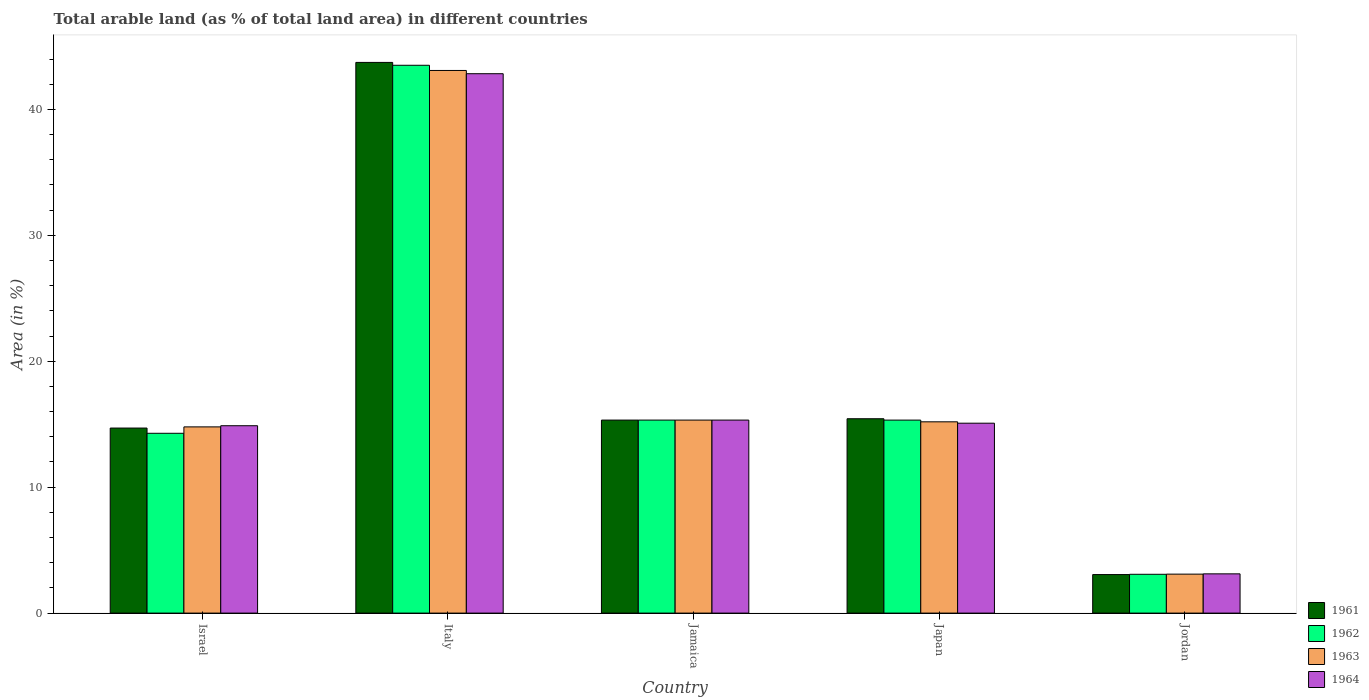What is the label of the 5th group of bars from the left?
Your answer should be compact. Jordan. What is the percentage of arable land in 1964 in Israel?
Offer a very short reply. 14.88. Across all countries, what is the maximum percentage of arable land in 1961?
Provide a succinct answer. 43.73. Across all countries, what is the minimum percentage of arable land in 1963?
Keep it short and to the point. 3.09. In which country was the percentage of arable land in 1962 minimum?
Provide a short and direct response. Jordan. What is the total percentage of arable land in 1962 in the graph?
Make the answer very short. 91.52. What is the difference between the percentage of arable land in 1964 in Israel and that in Japan?
Your response must be concise. -0.2. What is the difference between the percentage of arable land in 1963 in Jamaica and the percentage of arable land in 1964 in Italy?
Provide a succinct answer. -27.51. What is the average percentage of arable land in 1963 per country?
Offer a very short reply. 18.3. What is the difference between the percentage of arable land of/in 1961 and percentage of arable land of/in 1963 in Jordan?
Offer a very short reply. -0.03. What is the ratio of the percentage of arable land in 1961 in Italy to that in Japan?
Your response must be concise. 2.83. What is the difference between the highest and the second highest percentage of arable land in 1962?
Make the answer very short. 28.18. What is the difference between the highest and the lowest percentage of arable land in 1964?
Keep it short and to the point. 39.72. Is the sum of the percentage of arable land in 1962 in Jamaica and Japan greater than the maximum percentage of arable land in 1963 across all countries?
Your answer should be compact. No. Is it the case that in every country, the sum of the percentage of arable land in 1961 and percentage of arable land in 1962 is greater than the sum of percentage of arable land in 1964 and percentage of arable land in 1963?
Make the answer very short. No. What does the 1st bar from the right in Jamaica represents?
Keep it short and to the point. 1964. Is it the case that in every country, the sum of the percentage of arable land in 1964 and percentage of arable land in 1962 is greater than the percentage of arable land in 1963?
Make the answer very short. Yes. How many bars are there?
Make the answer very short. 20. Are all the bars in the graph horizontal?
Offer a very short reply. No. How many countries are there in the graph?
Provide a succinct answer. 5. Does the graph contain any zero values?
Give a very brief answer. No. What is the title of the graph?
Your answer should be very brief. Total arable land (as % of total land area) in different countries. Does "1996" appear as one of the legend labels in the graph?
Your response must be concise. No. What is the label or title of the X-axis?
Give a very brief answer. Country. What is the label or title of the Y-axis?
Make the answer very short. Area (in %). What is the Area (in %) of 1961 in Israel?
Your answer should be compact. 14.7. What is the Area (in %) in 1962 in Israel?
Make the answer very short. 14.28. What is the Area (in %) in 1963 in Israel?
Provide a succinct answer. 14.79. What is the Area (in %) of 1964 in Israel?
Give a very brief answer. 14.88. What is the Area (in %) of 1961 in Italy?
Offer a terse response. 43.73. What is the Area (in %) in 1962 in Italy?
Offer a very short reply. 43.5. What is the Area (in %) in 1963 in Italy?
Offer a terse response. 43.09. What is the Area (in %) in 1964 in Italy?
Your answer should be compact. 42.83. What is the Area (in %) in 1961 in Jamaica?
Provide a short and direct response. 15.33. What is the Area (in %) in 1962 in Jamaica?
Offer a terse response. 15.33. What is the Area (in %) in 1963 in Jamaica?
Make the answer very short. 15.33. What is the Area (in %) in 1964 in Jamaica?
Your response must be concise. 15.33. What is the Area (in %) in 1961 in Japan?
Your answer should be compact. 15.43. What is the Area (in %) of 1962 in Japan?
Your answer should be very brief. 15.33. What is the Area (in %) in 1963 in Japan?
Your response must be concise. 15.19. What is the Area (in %) of 1964 in Japan?
Provide a succinct answer. 15.08. What is the Area (in %) in 1961 in Jordan?
Provide a short and direct response. 3.06. What is the Area (in %) in 1962 in Jordan?
Provide a succinct answer. 3.08. What is the Area (in %) of 1963 in Jordan?
Provide a succinct answer. 3.09. What is the Area (in %) in 1964 in Jordan?
Make the answer very short. 3.12. Across all countries, what is the maximum Area (in %) in 1961?
Provide a short and direct response. 43.73. Across all countries, what is the maximum Area (in %) in 1962?
Your answer should be compact. 43.5. Across all countries, what is the maximum Area (in %) in 1963?
Provide a succinct answer. 43.09. Across all countries, what is the maximum Area (in %) of 1964?
Offer a terse response. 42.83. Across all countries, what is the minimum Area (in %) of 1961?
Make the answer very short. 3.06. Across all countries, what is the minimum Area (in %) in 1962?
Your answer should be very brief. 3.08. Across all countries, what is the minimum Area (in %) in 1963?
Provide a succinct answer. 3.09. Across all countries, what is the minimum Area (in %) in 1964?
Your answer should be very brief. 3.12. What is the total Area (in %) of 1961 in the graph?
Your answer should be compact. 92.25. What is the total Area (in %) in 1962 in the graph?
Your answer should be very brief. 91.52. What is the total Area (in %) of 1963 in the graph?
Provide a short and direct response. 91.49. What is the total Area (in %) in 1964 in the graph?
Give a very brief answer. 91.24. What is the difference between the Area (in %) in 1961 in Israel and that in Italy?
Your response must be concise. -29.04. What is the difference between the Area (in %) of 1962 in Israel and that in Italy?
Make the answer very short. -29.23. What is the difference between the Area (in %) in 1963 in Israel and that in Italy?
Your answer should be very brief. -28.31. What is the difference between the Area (in %) in 1964 in Israel and that in Italy?
Offer a very short reply. -27.95. What is the difference between the Area (in %) in 1961 in Israel and that in Jamaica?
Keep it short and to the point. -0.63. What is the difference between the Area (in %) of 1962 in Israel and that in Jamaica?
Ensure brevity in your answer.  -1.05. What is the difference between the Area (in %) in 1963 in Israel and that in Jamaica?
Your answer should be very brief. -0.54. What is the difference between the Area (in %) in 1964 in Israel and that in Jamaica?
Offer a very short reply. -0.45. What is the difference between the Area (in %) of 1961 in Israel and that in Japan?
Your response must be concise. -0.74. What is the difference between the Area (in %) in 1962 in Israel and that in Japan?
Give a very brief answer. -1.05. What is the difference between the Area (in %) of 1963 in Israel and that in Japan?
Your answer should be compact. -0.4. What is the difference between the Area (in %) in 1964 in Israel and that in Japan?
Your answer should be compact. -0.2. What is the difference between the Area (in %) of 1961 in Israel and that in Jordan?
Keep it short and to the point. 11.64. What is the difference between the Area (in %) in 1962 in Israel and that in Jordan?
Provide a short and direct response. 11.2. What is the difference between the Area (in %) in 1963 in Israel and that in Jordan?
Your answer should be compact. 11.69. What is the difference between the Area (in %) in 1964 in Israel and that in Jordan?
Keep it short and to the point. 11.76. What is the difference between the Area (in %) in 1961 in Italy and that in Jamaica?
Your response must be concise. 28.4. What is the difference between the Area (in %) of 1962 in Italy and that in Jamaica?
Make the answer very short. 28.18. What is the difference between the Area (in %) in 1963 in Italy and that in Jamaica?
Your answer should be very brief. 27.76. What is the difference between the Area (in %) in 1964 in Italy and that in Jamaica?
Make the answer very short. 27.51. What is the difference between the Area (in %) in 1961 in Italy and that in Japan?
Your answer should be very brief. 28.3. What is the difference between the Area (in %) in 1962 in Italy and that in Japan?
Provide a succinct answer. 28.18. What is the difference between the Area (in %) in 1963 in Italy and that in Japan?
Make the answer very short. 27.9. What is the difference between the Area (in %) in 1964 in Italy and that in Japan?
Give a very brief answer. 27.75. What is the difference between the Area (in %) of 1961 in Italy and that in Jordan?
Provide a short and direct response. 40.67. What is the difference between the Area (in %) of 1962 in Italy and that in Jordan?
Offer a terse response. 40.42. What is the difference between the Area (in %) of 1963 in Italy and that in Jordan?
Offer a terse response. 40. What is the difference between the Area (in %) in 1964 in Italy and that in Jordan?
Offer a terse response. 39.72. What is the difference between the Area (in %) in 1961 in Jamaica and that in Japan?
Your response must be concise. -0.11. What is the difference between the Area (in %) in 1962 in Jamaica and that in Japan?
Give a very brief answer. 0. What is the difference between the Area (in %) in 1963 in Jamaica and that in Japan?
Ensure brevity in your answer.  0.14. What is the difference between the Area (in %) in 1964 in Jamaica and that in Japan?
Provide a succinct answer. 0.25. What is the difference between the Area (in %) in 1961 in Jamaica and that in Jordan?
Your answer should be very brief. 12.27. What is the difference between the Area (in %) in 1962 in Jamaica and that in Jordan?
Give a very brief answer. 12.25. What is the difference between the Area (in %) of 1963 in Jamaica and that in Jordan?
Offer a very short reply. 12.23. What is the difference between the Area (in %) in 1964 in Jamaica and that in Jordan?
Provide a succinct answer. 12.21. What is the difference between the Area (in %) in 1961 in Japan and that in Jordan?
Offer a terse response. 12.38. What is the difference between the Area (in %) of 1962 in Japan and that in Jordan?
Make the answer very short. 12.24. What is the difference between the Area (in %) of 1963 in Japan and that in Jordan?
Your answer should be compact. 12.1. What is the difference between the Area (in %) of 1964 in Japan and that in Jordan?
Offer a very short reply. 11.96. What is the difference between the Area (in %) in 1961 in Israel and the Area (in %) in 1962 in Italy?
Keep it short and to the point. -28.81. What is the difference between the Area (in %) of 1961 in Israel and the Area (in %) of 1963 in Italy?
Keep it short and to the point. -28.4. What is the difference between the Area (in %) of 1961 in Israel and the Area (in %) of 1964 in Italy?
Provide a succinct answer. -28.14. What is the difference between the Area (in %) in 1962 in Israel and the Area (in %) in 1963 in Italy?
Provide a short and direct response. -28.81. What is the difference between the Area (in %) in 1962 in Israel and the Area (in %) in 1964 in Italy?
Your answer should be very brief. -28.56. What is the difference between the Area (in %) in 1963 in Israel and the Area (in %) in 1964 in Italy?
Your answer should be compact. -28.05. What is the difference between the Area (in %) of 1961 in Israel and the Area (in %) of 1962 in Jamaica?
Provide a short and direct response. -0.63. What is the difference between the Area (in %) of 1961 in Israel and the Area (in %) of 1963 in Jamaica?
Give a very brief answer. -0.63. What is the difference between the Area (in %) in 1961 in Israel and the Area (in %) in 1964 in Jamaica?
Your answer should be compact. -0.63. What is the difference between the Area (in %) in 1962 in Israel and the Area (in %) in 1963 in Jamaica?
Provide a succinct answer. -1.05. What is the difference between the Area (in %) in 1962 in Israel and the Area (in %) in 1964 in Jamaica?
Your answer should be very brief. -1.05. What is the difference between the Area (in %) of 1963 in Israel and the Area (in %) of 1964 in Jamaica?
Your answer should be very brief. -0.54. What is the difference between the Area (in %) in 1961 in Israel and the Area (in %) in 1962 in Japan?
Offer a very short reply. -0.63. What is the difference between the Area (in %) of 1961 in Israel and the Area (in %) of 1963 in Japan?
Give a very brief answer. -0.49. What is the difference between the Area (in %) of 1961 in Israel and the Area (in %) of 1964 in Japan?
Keep it short and to the point. -0.39. What is the difference between the Area (in %) of 1962 in Israel and the Area (in %) of 1963 in Japan?
Make the answer very short. -0.91. What is the difference between the Area (in %) in 1962 in Israel and the Area (in %) in 1964 in Japan?
Keep it short and to the point. -0.8. What is the difference between the Area (in %) in 1963 in Israel and the Area (in %) in 1964 in Japan?
Provide a succinct answer. -0.29. What is the difference between the Area (in %) in 1961 in Israel and the Area (in %) in 1962 in Jordan?
Offer a terse response. 11.61. What is the difference between the Area (in %) in 1961 in Israel and the Area (in %) in 1963 in Jordan?
Offer a very short reply. 11.6. What is the difference between the Area (in %) in 1961 in Israel and the Area (in %) in 1964 in Jordan?
Provide a succinct answer. 11.58. What is the difference between the Area (in %) of 1962 in Israel and the Area (in %) of 1963 in Jordan?
Offer a very short reply. 11.19. What is the difference between the Area (in %) of 1962 in Israel and the Area (in %) of 1964 in Jordan?
Provide a short and direct response. 11.16. What is the difference between the Area (in %) in 1963 in Israel and the Area (in %) in 1964 in Jordan?
Provide a succinct answer. 11.67. What is the difference between the Area (in %) in 1961 in Italy and the Area (in %) in 1962 in Jamaica?
Keep it short and to the point. 28.4. What is the difference between the Area (in %) of 1961 in Italy and the Area (in %) of 1963 in Jamaica?
Your answer should be very brief. 28.4. What is the difference between the Area (in %) in 1961 in Italy and the Area (in %) in 1964 in Jamaica?
Provide a succinct answer. 28.4. What is the difference between the Area (in %) of 1962 in Italy and the Area (in %) of 1963 in Jamaica?
Ensure brevity in your answer.  28.18. What is the difference between the Area (in %) in 1962 in Italy and the Area (in %) in 1964 in Jamaica?
Your answer should be compact. 28.18. What is the difference between the Area (in %) of 1963 in Italy and the Area (in %) of 1964 in Jamaica?
Ensure brevity in your answer.  27.76. What is the difference between the Area (in %) of 1961 in Italy and the Area (in %) of 1962 in Japan?
Ensure brevity in your answer.  28.41. What is the difference between the Area (in %) of 1961 in Italy and the Area (in %) of 1963 in Japan?
Keep it short and to the point. 28.54. What is the difference between the Area (in %) in 1961 in Italy and the Area (in %) in 1964 in Japan?
Give a very brief answer. 28.65. What is the difference between the Area (in %) in 1962 in Italy and the Area (in %) in 1963 in Japan?
Ensure brevity in your answer.  28.31. What is the difference between the Area (in %) of 1962 in Italy and the Area (in %) of 1964 in Japan?
Provide a short and direct response. 28.42. What is the difference between the Area (in %) of 1963 in Italy and the Area (in %) of 1964 in Japan?
Your response must be concise. 28.01. What is the difference between the Area (in %) in 1961 in Italy and the Area (in %) in 1962 in Jordan?
Ensure brevity in your answer.  40.65. What is the difference between the Area (in %) in 1961 in Italy and the Area (in %) in 1963 in Jordan?
Offer a very short reply. 40.64. What is the difference between the Area (in %) of 1961 in Italy and the Area (in %) of 1964 in Jordan?
Your answer should be compact. 40.62. What is the difference between the Area (in %) of 1962 in Italy and the Area (in %) of 1963 in Jordan?
Offer a very short reply. 40.41. What is the difference between the Area (in %) of 1962 in Italy and the Area (in %) of 1964 in Jordan?
Give a very brief answer. 40.39. What is the difference between the Area (in %) of 1963 in Italy and the Area (in %) of 1964 in Jordan?
Make the answer very short. 39.98. What is the difference between the Area (in %) in 1961 in Jamaica and the Area (in %) in 1962 in Japan?
Offer a very short reply. 0. What is the difference between the Area (in %) of 1961 in Jamaica and the Area (in %) of 1963 in Japan?
Ensure brevity in your answer.  0.14. What is the difference between the Area (in %) in 1961 in Jamaica and the Area (in %) in 1964 in Japan?
Give a very brief answer. 0.25. What is the difference between the Area (in %) of 1962 in Jamaica and the Area (in %) of 1963 in Japan?
Your response must be concise. 0.14. What is the difference between the Area (in %) in 1962 in Jamaica and the Area (in %) in 1964 in Japan?
Provide a short and direct response. 0.25. What is the difference between the Area (in %) in 1963 in Jamaica and the Area (in %) in 1964 in Japan?
Your answer should be compact. 0.25. What is the difference between the Area (in %) in 1961 in Jamaica and the Area (in %) in 1962 in Jordan?
Offer a terse response. 12.25. What is the difference between the Area (in %) of 1961 in Jamaica and the Area (in %) of 1963 in Jordan?
Provide a succinct answer. 12.23. What is the difference between the Area (in %) in 1961 in Jamaica and the Area (in %) in 1964 in Jordan?
Ensure brevity in your answer.  12.21. What is the difference between the Area (in %) of 1962 in Jamaica and the Area (in %) of 1963 in Jordan?
Your answer should be very brief. 12.23. What is the difference between the Area (in %) in 1962 in Jamaica and the Area (in %) in 1964 in Jordan?
Make the answer very short. 12.21. What is the difference between the Area (in %) in 1963 in Jamaica and the Area (in %) in 1964 in Jordan?
Your answer should be very brief. 12.21. What is the difference between the Area (in %) in 1961 in Japan and the Area (in %) in 1962 in Jordan?
Your response must be concise. 12.35. What is the difference between the Area (in %) of 1961 in Japan and the Area (in %) of 1963 in Jordan?
Offer a very short reply. 12.34. What is the difference between the Area (in %) of 1961 in Japan and the Area (in %) of 1964 in Jordan?
Provide a short and direct response. 12.32. What is the difference between the Area (in %) of 1962 in Japan and the Area (in %) of 1963 in Jordan?
Your response must be concise. 12.23. What is the difference between the Area (in %) of 1962 in Japan and the Area (in %) of 1964 in Jordan?
Your answer should be very brief. 12.21. What is the difference between the Area (in %) of 1963 in Japan and the Area (in %) of 1964 in Jordan?
Your answer should be compact. 12.07. What is the average Area (in %) in 1961 per country?
Your answer should be very brief. 18.45. What is the average Area (in %) of 1962 per country?
Provide a short and direct response. 18.3. What is the average Area (in %) of 1963 per country?
Keep it short and to the point. 18.3. What is the average Area (in %) in 1964 per country?
Offer a terse response. 18.25. What is the difference between the Area (in %) of 1961 and Area (in %) of 1962 in Israel?
Keep it short and to the point. 0.42. What is the difference between the Area (in %) in 1961 and Area (in %) in 1963 in Israel?
Keep it short and to the point. -0.09. What is the difference between the Area (in %) of 1961 and Area (in %) of 1964 in Israel?
Keep it short and to the point. -0.18. What is the difference between the Area (in %) of 1962 and Area (in %) of 1963 in Israel?
Your answer should be compact. -0.51. What is the difference between the Area (in %) of 1962 and Area (in %) of 1964 in Israel?
Make the answer very short. -0.6. What is the difference between the Area (in %) in 1963 and Area (in %) in 1964 in Israel?
Make the answer very short. -0.09. What is the difference between the Area (in %) of 1961 and Area (in %) of 1962 in Italy?
Offer a terse response. 0.23. What is the difference between the Area (in %) of 1961 and Area (in %) of 1963 in Italy?
Ensure brevity in your answer.  0.64. What is the difference between the Area (in %) of 1961 and Area (in %) of 1964 in Italy?
Give a very brief answer. 0.9. What is the difference between the Area (in %) of 1962 and Area (in %) of 1963 in Italy?
Your answer should be compact. 0.41. What is the difference between the Area (in %) in 1962 and Area (in %) in 1964 in Italy?
Your response must be concise. 0.67. What is the difference between the Area (in %) of 1963 and Area (in %) of 1964 in Italy?
Provide a succinct answer. 0.26. What is the difference between the Area (in %) in 1961 and Area (in %) in 1963 in Jamaica?
Offer a very short reply. 0. What is the difference between the Area (in %) of 1962 and Area (in %) of 1963 in Jamaica?
Provide a short and direct response. 0. What is the difference between the Area (in %) of 1963 and Area (in %) of 1964 in Jamaica?
Make the answer very short. 0. What is the difference between the Area (in %) of 1961 and Area (in %) of 1962 in Japan?
Provide a succinct answer. 0.11. What is the difference between the Area (in %) in 1961 and Area (in %) in 1963 in Japan?
Your answer should be compact. 0.25. What is the difference between the Area (in %) in 1961 and Area (in %) in 1964 in Japan?
Your answer should be compact. 0.35. What is the difference between the Area (in %) in 1962 and Area (in %) in 1963 in Japan?
Provide a succinct answer. 0.14. What is the difference between the Area (in %) of 1962 and Area (in %) of 1964 in Japan?
Ensure brevity in your answer.  0.25. What is the difference between the Area (in %) of 1963 and Area (in %) of 1964 in Japan?
Offer a very short reply. 0.11. What is the difference between the Area (in %) in 1961 and Area (in %) in 1962 in Jordan?
Make the answer very short. -0.02. What is the difference between the Area (in %) in 1961 and Area (in %) in 1963 in Jordan?
Provide a short and direct response. -0.03. What is the difference between the Area (in %) of 1961 and Area (in %) of 1964 in Jordan?
Offer a terse response. -0.06. What is the difference between the Area (in %) of 1962 and Area (in %) of 1963 in Jordan?
Provide a succinct answer. -0.01. What is the difference between the Area (in %) of 1962 and Area (in %) of 1964 in Jordan?
Your response must be concise. -0.03. What is the difference between the Area (in %) in 1963 and Area (in %) in 1964 in Jordan?
Your answer should be very brief. -0.02. What is the ratio of the Area (in %) in 1961 in Israel to that in Italy?
Make the answer very short. 0.34. What is the ratio of the Area (in %) of 1962 in Israel to that in Italy?
Offer a very short reply. 0.33. What is the ratio of the Area (in %) of 1963 in Israel to that in Italy?
Your answer should be very brief. 0.34. What is the ratio of the Area (in %) of 1964 in Israel to that in Italy?
Offer a terse response. 0.35. What is the ratio of the Area (in %) in 1961 in Israel to that in Jamaica?
Provide a short and direct response. 0.96. What is the ratio of the Area (in %) of 1962 in Israel to that in Jamaica?
Provide a short and direct response. 0.93. What is the ratio of the Area (in %) in 1963 in Israel to that in Jamaica?
Your answer should be compact. 0.96. What is the ratio of the Area (in %) in 1964 in Israel to that in Jamaica?
Give a very brief answer. 0.97. What is the ratio of the Area (in %) in 1961 in Israel to that in Japan?
Give a very brief answer. 0.95. What is the ratio of the Area (in %) in 1962 in Israel to that in Japan?
Provide a succinct answer. 0.93. What is the ratio of the Area (in %) of 1963 in Israel to that in Japan?
Keep it short and to the point. 0.97. What is the ratio of the Area (in %) of 1964 in Israel to that in Japan?
Provide a short and direct response. 0.99. What is the ratio of the Area (in %) in 1961 in Israel to that in Jordan?
Give a very brief answer. 4.8. What is the ratio of the Area (in %) in 1962 in Israel to that in Jordan?
Provide a succinct answer. 4.63. What is the ratio of the Area (in %) in 1963 in Israel to that in Jordan?
Your answer should be compact. 4.78. What is the ratio of the Area (in %) of 1964 in Israel to that in Jordan?
Provide a short and direct response. 4.77. What is the ratio of the Area (in %) in 1961 in Italy to that in Jamaica?
Your answer should be very brief. 2.85. What is the ratio of the Area (in %) in 1962 in Italy to that in Jamaica?
Provide a short and direct response. 2.84. What is the ratio of the Area (in %) in 1963 in Italy to that in Jamaica?
Give a very brief answer. 2.81. What is the ratio of the Area (in %) of 1964 in Italy to that in Jamaica?
Ensure brevity in your answer.  2.79. What is the ratio of the Area (in %) of 1961 in Italy to that in Japan?
Offer a terse response. 2.83. What is the ratio of the Area (in %) in 1962 in Italy to that in Japan?
Your answer should be very brief. 2.84. What is the ratio of the Area (in %) of 1963 in Italy to that in Japan?
Offer a terse response. 2.84. What is the ratio of the Area (in %) in 1964 in Italy to that in Japan?
Give a very brief answer. 2.84. What is the ratio of the Area (in %) in 1961 in Italy to that in Jordan?
Keep it short and to the point. 14.29. What is the ratio of the Area (in %) in 1962 in Italy to that in Jordan?
Provide a succinct answer. 14.11. What is the ratio of the Area (in %) of 1963 in Italy to that in Jordan?
Give a very brief answer. 13.93. What is the ratio of the Area (in %) in 1964 in Italy to that in Jordan?
Give a very brief answer. 13.74. What is the ratio of the Area (in %) in 1961 in Jamaica to that in Japan?
Your answer should be compact. 0.99. What is the ratio of the Area (in %) of 1962 in Jamaica to that in Japan?
Make the answer very short. 1. What is the ratio of the Area (in %) of 1963 in Jamaica to that in Japan?
Offer a terse response. 1.01. What is the ratio of the Area (in %) in 1964 in Jamaica to that in Japan?
Offer a very short reply. 1.02. What is the ratio of the Area (in %) of 1961 in Jamaica to that in Jordan?
Make the answer very short. 5.01. What is the ratio of the Area (in %) of 1962 in Jamaica to that in Jordan?
Your answer should be compact. 4.97. What is the ratio of the Area (in %) of 1963 in Jamaica to that in Jordan?
Offer a terse response. 4.95. What is the ratio of the Area (in %) in 1964 in Jamaica to that in Jordan?
Give a very brief answer. 4.92. What is the ratio of the Area (in %) of 1961 in Japan to that in Jordan?
Give a very brief answer. 5.04. What is the ratio of the Area (in %) in 1962 in Japan to that in Jordan?
Provide a short and direct response. 4.97. What is the ratio of the Area (in %) in 1963 in Japan to that in Jordan?
Provide a short and direct response. 4.91. What is the ratio of the Area (in %) in 1964 in Japan to that in Jordan?
Provide a succinct answer. 4.84. What is the difference between the highest and the second highest Area (in %) of 1961?
Your response must be concise. 28.3. What is the difference between the highest and the second highest Area (in %) in 1962?
Make the answer very short. 28.18. What is the difference between the highest and the second highest Area (in %) of 1963?
Make the answer very short. 27.76. What is the difference between the highest and the second highest Area (in %) of 1964?
Make the answer very short. 27.51. What is the difference between the highest and the lowest Area (in %) in 1961?
Make the answer very short. 40.67. What is the difference between the highest and the lowest Area (in %) of 1962?
Your answer should be compact. 40.42. What is the difference between the highest and the lowest Area (in %) of 1963?
Offer a terse response. 40. What is the difference between the highest and the lowest Area (in %) in 1964?
Provide a short and direct response. 39.72. 